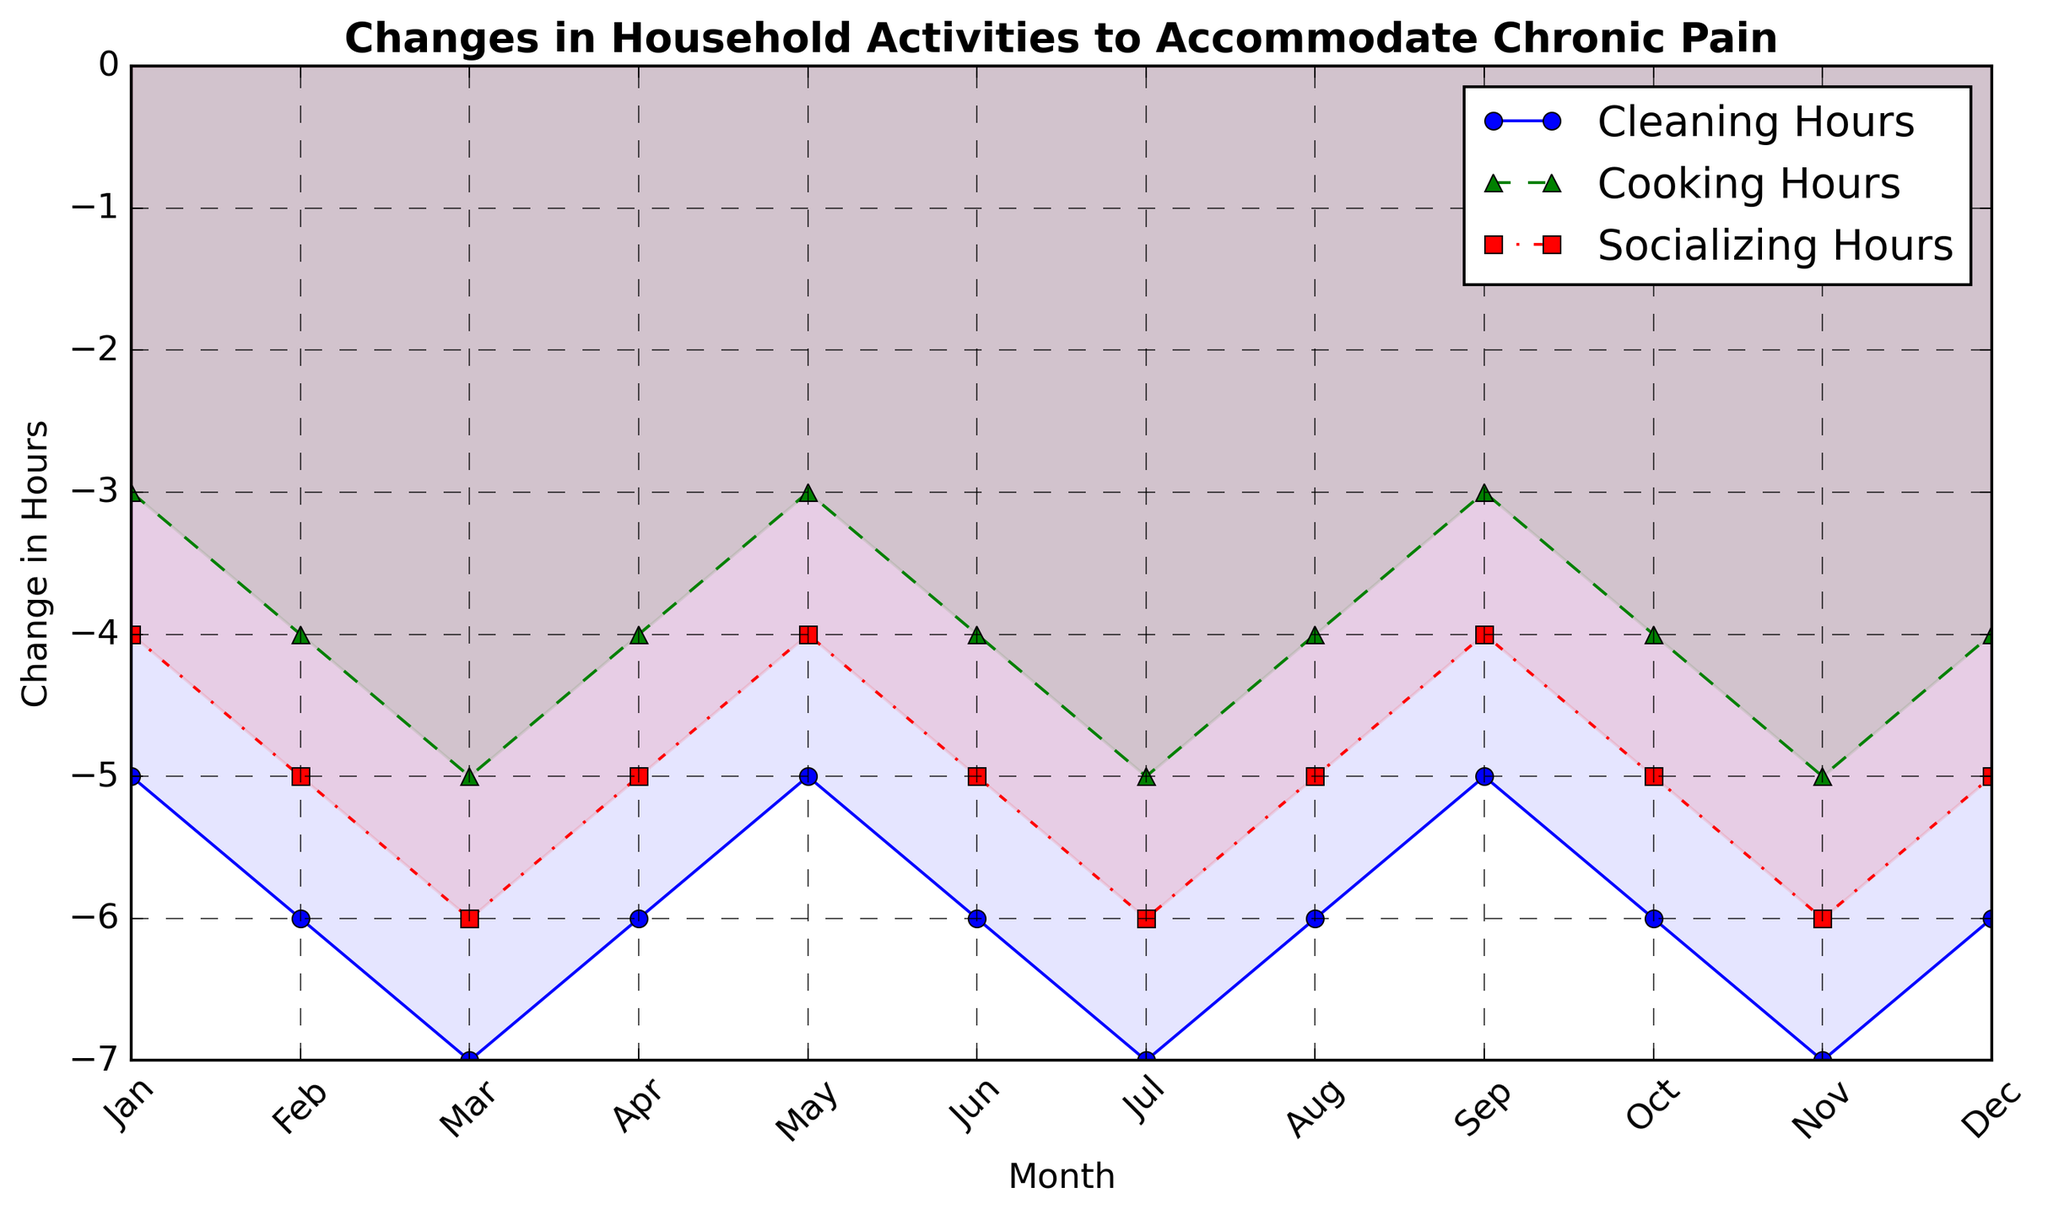Which activity shows the most significant reduction in hours throughout the year? By examining the plot, we can see that "Change in Socializing Hours" consistently shows the lowest values each month. Thus, socializing has the most significant reduction in hours.
Answer: Socializing Which month shows the smallest reduction in cleaning hours? Looking at the plot, the month with the highest points for "Change in Cleaning Hours" is January, indicating the smallest reduction.
Answer: January What is the average reduction in cooking hours over the year? To find the average reduction, sum all the changes in cooking hours and divide by the number of months. Sum = (-3) + (-4) + (-5) + (-4) + (-3) + (-4) + (-5) + (-4) + (-3) + (-4) + (-5) + (-4) = -48. There are 12 months, so the average is -48 / 12.
Answer: -4 How does the reduction in cleaning hours in November compare to that in February? According to the plot, both November and February show a reduction of -7 hours in cleaning, indicating they are equal.
Answer: Equal What is the total reduction in socializing hours in the first quarter (Jan, Feb, Mar)? The sum of the reductions for socializing in the first quarter is (-4) + (-5) + (-6) = -15.
Answer: -15 In which month does the reduction in socializing and cooking hours differ the most? Inspecting the plot, the month with the largest visual gap between "Change in Socializing Hours" and "Change in Cooking Hours" is March. The difference is (-6) - (-5) = -1 in all cases, making the changes equally different when rounded but March has slightly more visible difference.
Answer: March Is there any month where the reduction in cooking and cleaning hours is the same? By looking at the plot, no month shows the same level of reduction in both cooking and cleaning hours.
Answer: No Are the changes in hours generally consistent month to month, or are there any outliers? The trend lines for all activities show a consistent pattern without sharp deviations across months.
Answer: Consistent 